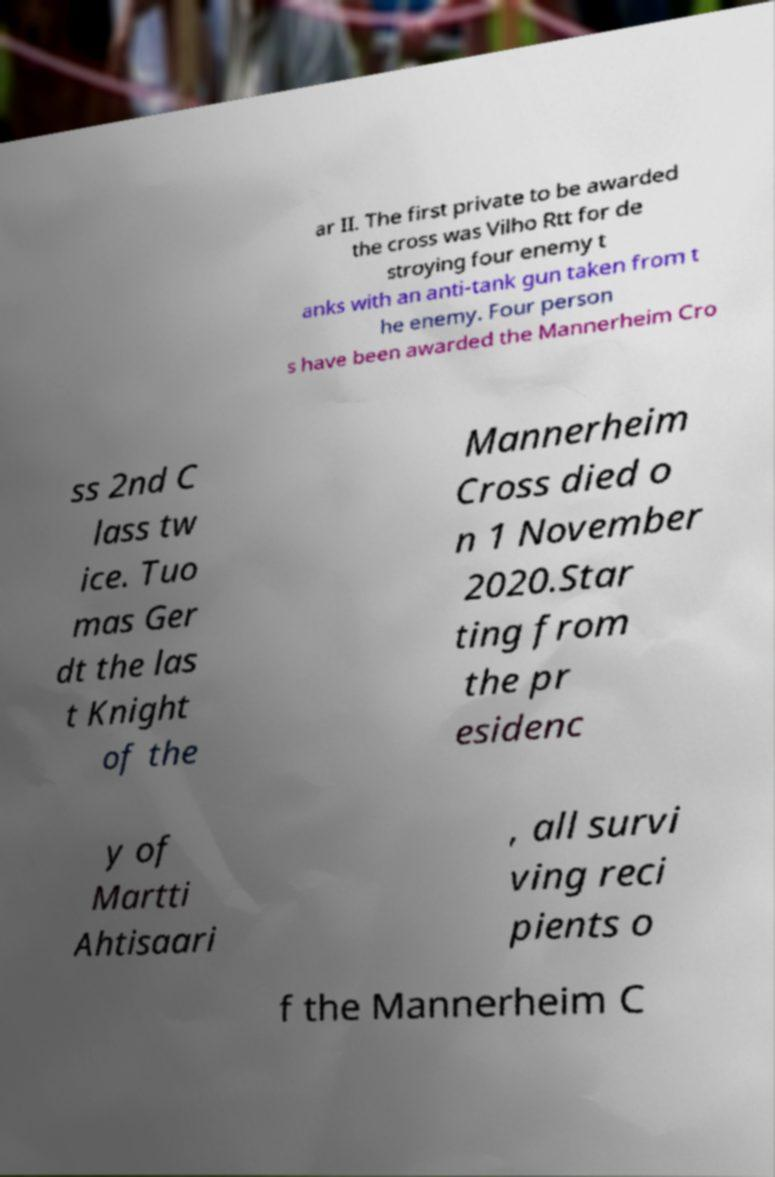There's text embedded in this image that I need extracted. Can you transcribe it verbatim? ar II. The first private to be awarded the cross was Vilho Rtt for de stroying four enemy t anks with an anti-tank gun taken from t he enemy. Four person s have been awarded the Mannerheim Cro ss 2nd C lass tw ice. Tuo mas Ger dt the las t Knight of the Mannerheim Cross died o n 1 November 2020.Star ting from the pr esidenc y of Martti Ahtisaari , all survi ving reci pients o f the Mannerheim C 